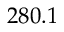Convert formula to latex. <formula><loc_0><loc_0><loc_500><loc_500>2 8 0 . 1</formula> 